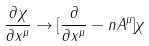Convert formula to latex. <formula><loc_0><loc_0><loc_500><loc_500>\frac { \partial \chi } { \partial x ^ { \mu } } \to [ \frac { \partial } { \partial x ^ { \mu } } - n A ^ { \mu } ] \chi</formula> 